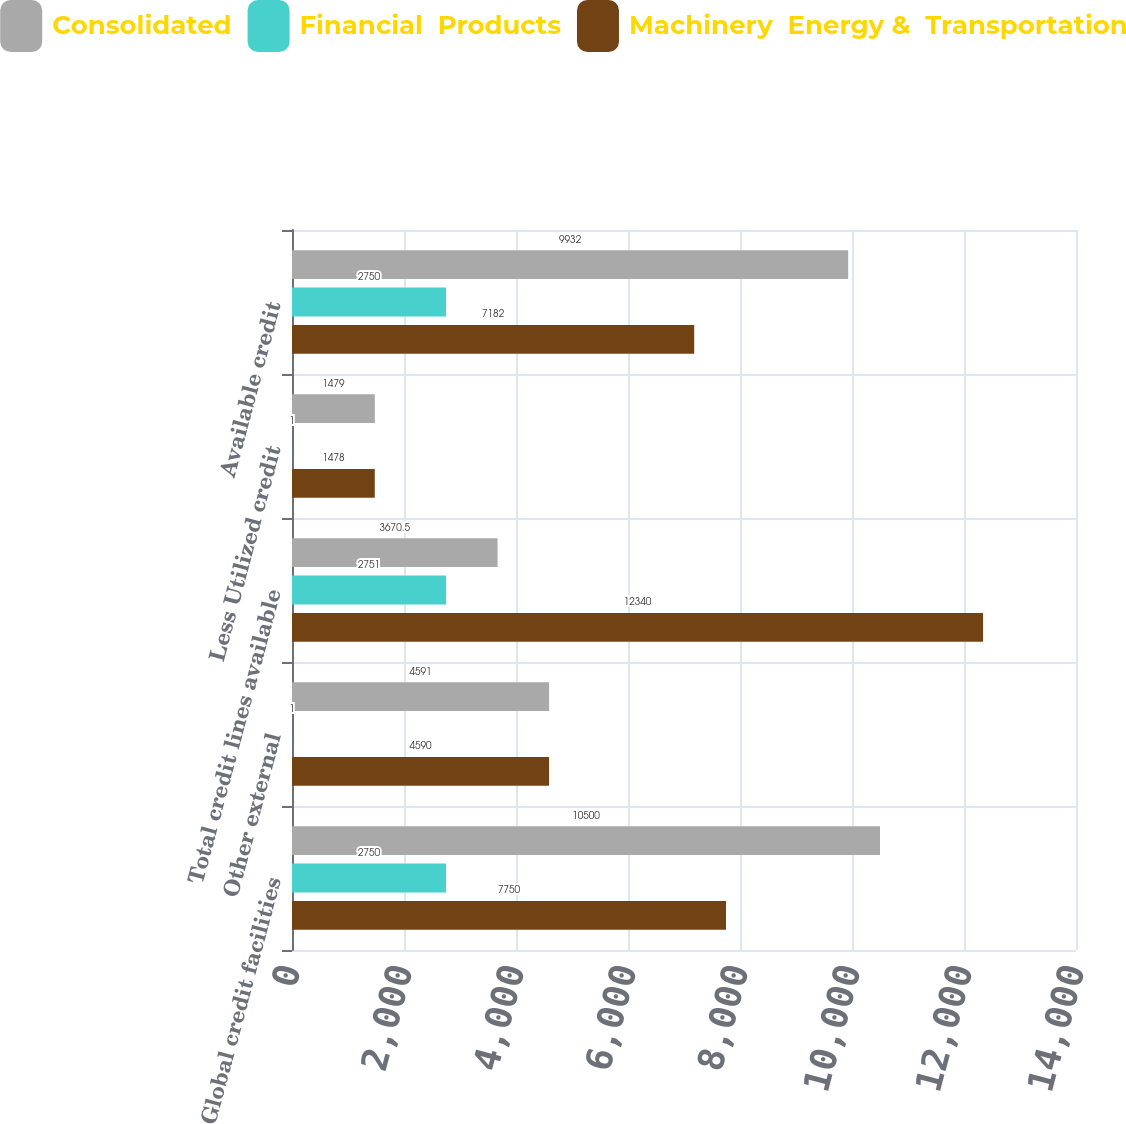Convert chart. <chart><loc_0><loc_0><loc_500><loc_500><stacked_bar_chart><ecel><fcel>Global credit facilities<fcel>Other external<fcel>Total credit lines available<fcel>Less Utilized credit<fcel>Available credit<nl><fcel>Consolidated<fcel>10500<fcel>4591<fcel>3670.5<fcel>1479<fcel>9932<nl><fcel>Financial  Products<fcel>2750<fcel>1<fcel>2751<fcel>1<fcel>2750<nl><fcel>Machinery  Energy &  Transportation<fcel>7750<fcel>4590<fcel>12340<fcel>1478<fcel>7182<nl></chart> 